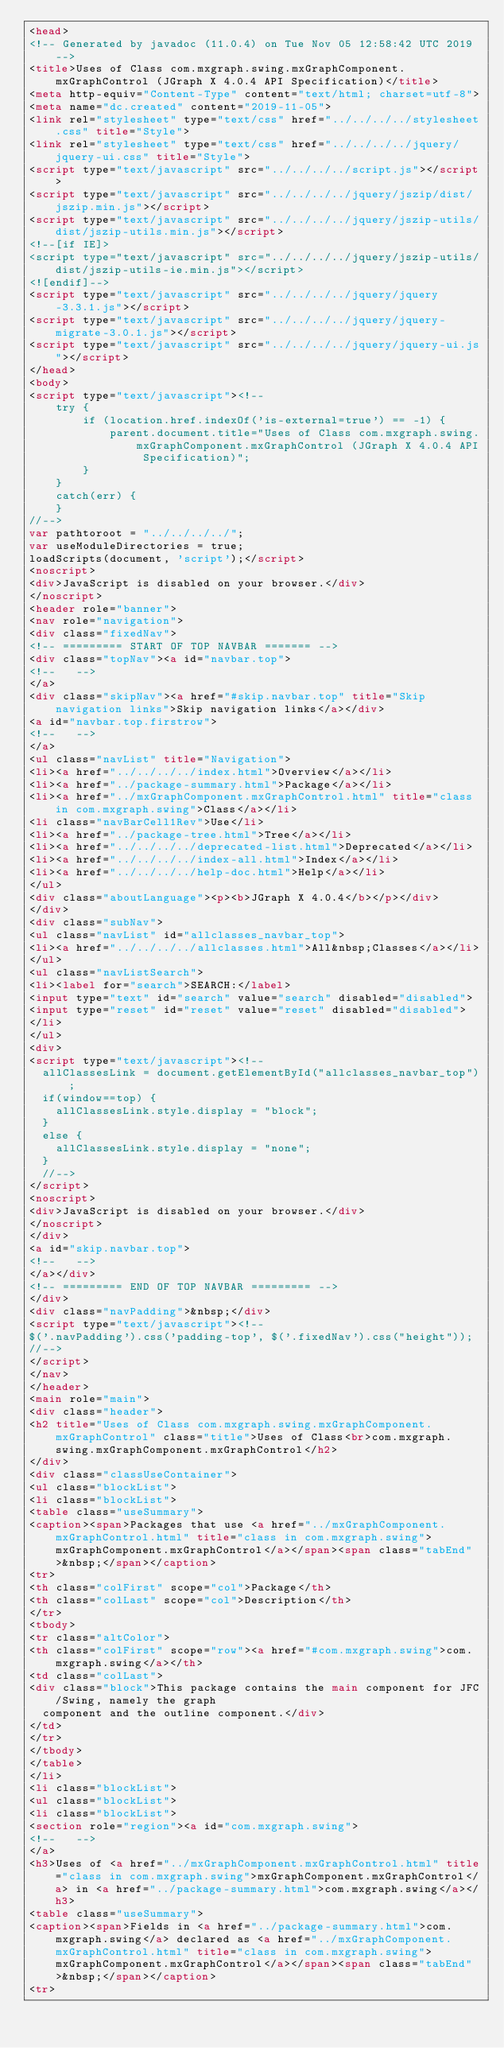<code> <loc_0><loc_0><loc_500><loc_500><_HTML_><head>
<!-- Generated by javadoc (11.0.4) on Tue Nov 05 12:58:42 UTC 2019 -->
<title>Uses of Class com.mxgraph.swing.mxGraphComponent.mxGraphControl (JGraph X 4.0.4 API Specification)</title>
<meta http-equiv="Content-Type" content="text/html; charset=utf-8">
<meta name="dc.created" content="2019-11-05">
<link rel="stylesheet" type="text/css" href="../../../../stylesheet.css" title="Style">
<link rel="stylesheet" type="text/css" href="../../../../jquery/jquery-ui.css" title="Style">
<script type="text/javascript" src="../../../../script.js"></script>
<script type="text/javascript" src="../../../../jquery/jszip/dist/jszip.min.js"></script>
<script type="text/javascript" src="../../../../jquery/jszip-utils/dist/jszip-utils.min.js"></script>
<!--[if IE]>
<script type="text/javascript" src="../../../../jquery/jszip-utils/dist/jszip-utils-ie.min.js"></script>
<![endif]-->
<script type="text/javascript" src="../../../../jquery/jquery-3.3.1.js"></script>
<script type="text/javascript" src="../../../../jquery/jquery-migrate-3.0.1.js"></script>
<script type="text/javascript" src="../../../../jquery/jquery-ui.js"></script>
</head>
<body>
<script type="text/javascript"><!--
    try {
        if (location.href.indexOf('is-external=true') == -1) {
            parent.document.title="Uses of Class com.mxgraph.swing.mxGraphComponent.mxGraphControl (JGraph X 4.0.4 API Specification)";
        }
    }
    catch(err) {
    }
//-->
var pathtoroot = "../../../../";
var useModuleDirectories = true;
loadScripts(document, 'script');</script>
<noscript>
<div>JavaScript is disabled on your browser.</div>
</noscript>
<header role="banner">
<nav role="navigation">
<div class="fixedNav">
<!-- ========= START OF TOP NAVBAR ======= -->
<div class="topNav"><a id="navbar.top">
<!--   -->
</a>
<div class="skipNav"><a href="#skip.navbar.top" title="Skip navigation links">Skip navigation links</a></div>
<a id="navbar.top.firstrow">
<!--   -->
</a>
<ul class="navList" title="Navigation">
<li><a href="../../../../index.html">Overview</a></li>
<li><a href="../package-summary.html">Package</a></li>
<li><a href="../mxGraphComponent.mxGraphControl.html" title="class in com.mxgraph.swing">Class</a></li>
<li class="navBarCell1Rev">Use</li>
<li><a href="../package-tree.html">Tree</a></li>
<li><a href="../../../../deprecated-list.html">Deprecated</a></li>
<li><a href="../../../../index-all.html">Index</a></li>
<li><a href="../../../../help-doc.html">Help</a></li>
</ul>
<div class="aboutLanguage"><p><b>JGraph X 4.0.4</b></p></div>
</div>
<div class="subNav">
<ul class="navList" id="allclasses_navbar_top">
<li><a href="../../../../allclasses.html">All&nbsp;Classes</a></li>
</ul>
<ul class="navListSearch">
<li><label for="search">SEARCH:</label>
<input type="text" id="search" value="search" disabled="disabled">
<input type="reset" id="reset" value="reset" disabled="disabled">
</li>
</ul>
<div>
<script type="text/javascript"><!--
  allClassesLink = document.getElementById("allclasses_navbar_top");
  if(window==top) {
    allClassesLink.style.display = "block";
  }
  else {
    allClassesLink.style.display = "none";
  }
  //-->
</script>
<noscript>
<div>JavaScript is disabled on your browser.</div>
</noscript>
</div>
<a id="skip.navbar.top">
<!--   -->
</a></div>
<!-- ========= END OF TOP NAVBAR ========= -->
</div>
<div class="navPadding">&nbsp;</div>
<script type="text/javascript"><!--
$('.navPadding').css('padding-top', $('.fixedNav').css("height"));
//-->
</script>
</nav>
</header>
<main role="main">
<div class="header">
<h2 title="Uses of Class com.mxgraph.swing.mxGraphComponent.mxGraphControl" class="title">Uses of Class<br>com.mxgraph.swing.mxGraphComponent.mxGraphControl</h2>
</div>
<div class="classUseContainer">
<ul class="blockList">
<li class="blockList">
<table class="useSummary">
<caption><span>Packages that use <a href="../mxGraphComponent.mxGraphControl.html" title="class in com.mxgraph.swing">mxGraphComponent.mxGraphControl</a></span><span class="tabEnd">&nbsp;</span></caption>
<tr>
<th class="colFirst" scope="col">Package</th>
<th class="colLast" scope="col">Description</th>
</tr>
<tbody>
<tr class="altColor">
<th class="colFirst" scope="row"><a href="#com.mxgraph.swing">com.mxgraph.swing</a></th>
<td class="colLast">
<div class="block">This package contains the main component for JFC/Swing, namely the graph
  component and the outline component.</div>
</td>
</tr>
</tbody>
</table>
</li>
<li class="blockList">
<ul class="blockList">
<li class="blockList">
<section role="region"><a id="com.mxgraph.swing">
<!--   -->
</a>
<h3>Uses of <a href="../mxGraphComponent.mxGraphControl.html" title="class in com.mxgraph.swing">mxGraphComponent.mxGraphControl</a> in <a href="../package-summary.html">com.mxgraph.swing</a></h3>
<table class="useSummary">
<caption><span>Fields in <a href="../package-summary.html">com.mxgraph.swing</a> declared as <a href="../mxGraphComponent.mxGraphControl.html" title="class in com.mxgraph.swing">mxGraphComponent.mxGraphControl</a></span><span class="tabEnd">&nbsp;</span></caption>
<tr></code> 